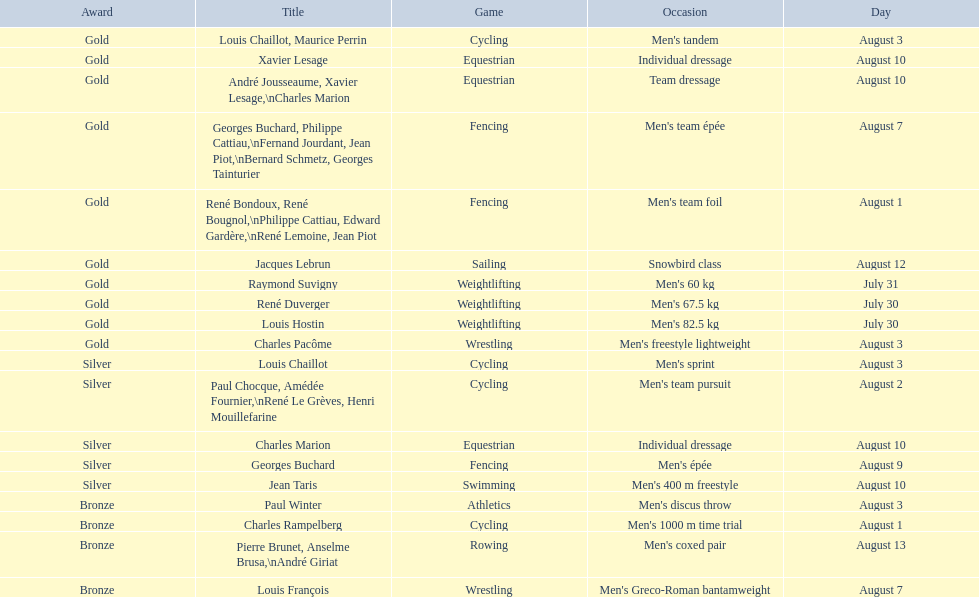Louis chaillot won a gold medal for cycling and a silver medal for what sport? Cycling. 